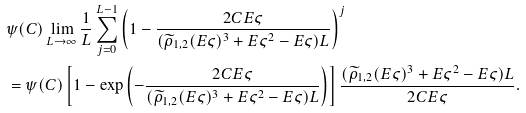Convert formula to latex. <formula><loc_0><loc_0><loc_500><loc_500>& \psi ( C ) \lim _ { L \to \infty } \frac { 1 } { L } \sum _ { j = 0 } ^ { L - 1 } \left ( 1 - \frac { 2 C E \varsigma } { ( \widetilde { \rho } _ { 1 , 2 } ( E \varsigma ) ^ { 3 } + E \varsigma ^ { 2 } - E \varsigma ) L } \right ) ^ { j } \\ & = \psi ( C ) \left [ 1 - \exp \left ( - \frac { 2 C E \varsigma } { ( \widetilde { \rho } _ { 1 , 2 } ( E \varsigma ) ^ { 3 } + E \varsigma ^ { 2 } - E \varsigma ) L } \right ) \right ] \frac { ( \widetilde { \rho } _ { 1 , 2 } ( E \varsigma ) ^ { 3 } + E \varsigma ^ { 2 } - E \varsigma ) L } { 2 C E \varsigma } .</formula> 